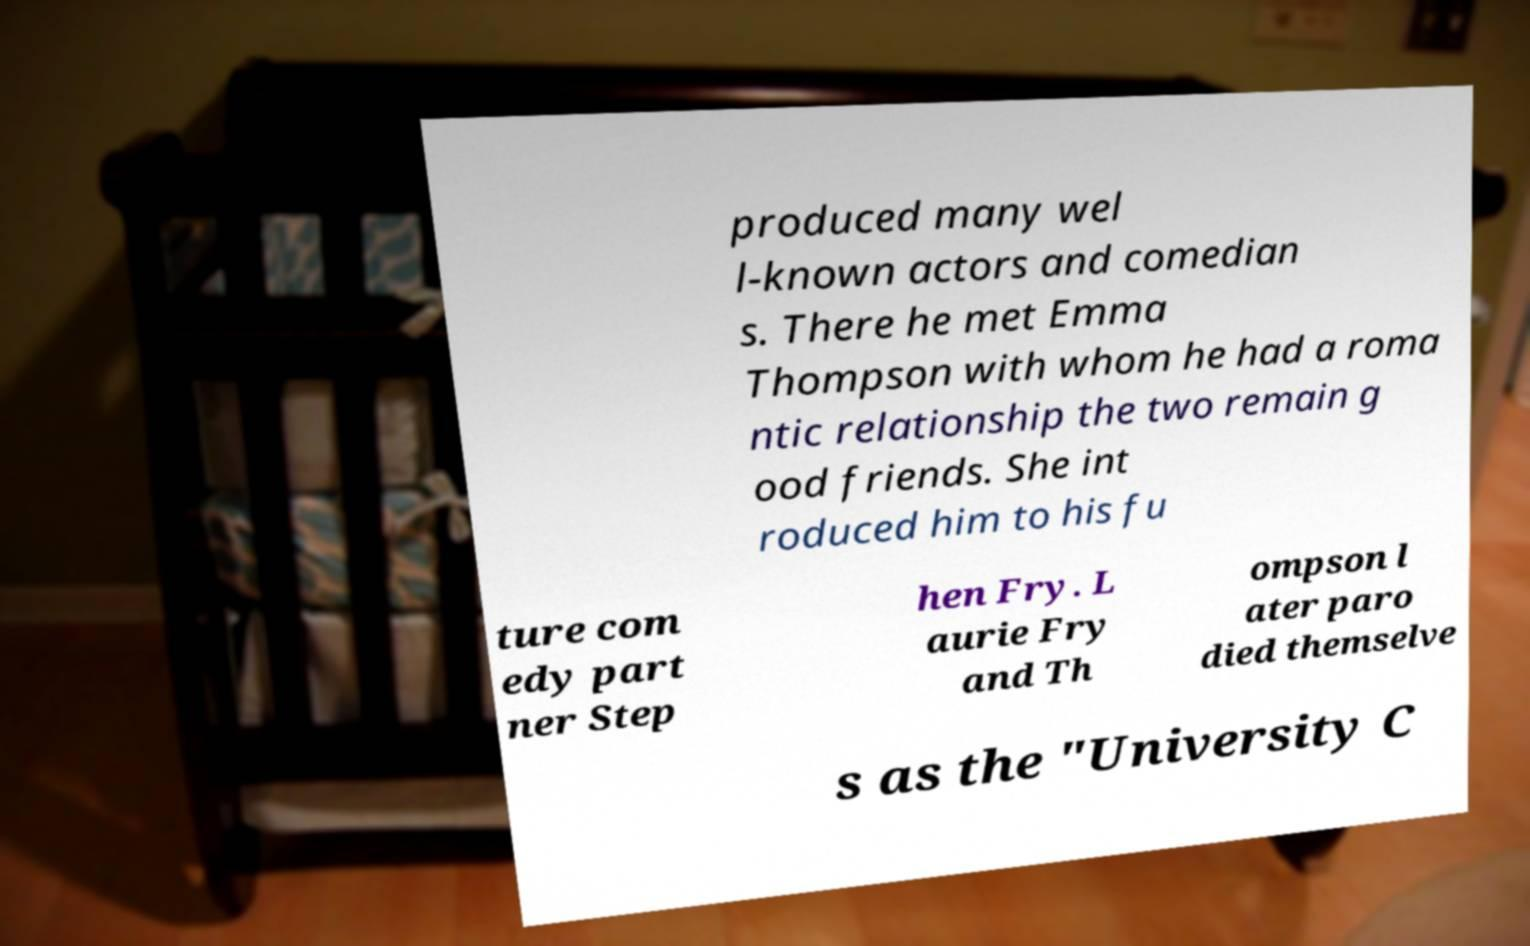For documentation purposes, I need the text within this image transcribed. Could you provide that? produced many wel l-known actors and comedian s. There he met Emma Thompson with whom he had a roma ntic relationship the two remain g ood friends. She int roduced him to his fu ture com edy part ner Step hen Fry. L aurie Fry and Th ompson l ater paro died themselve s as the "University C 